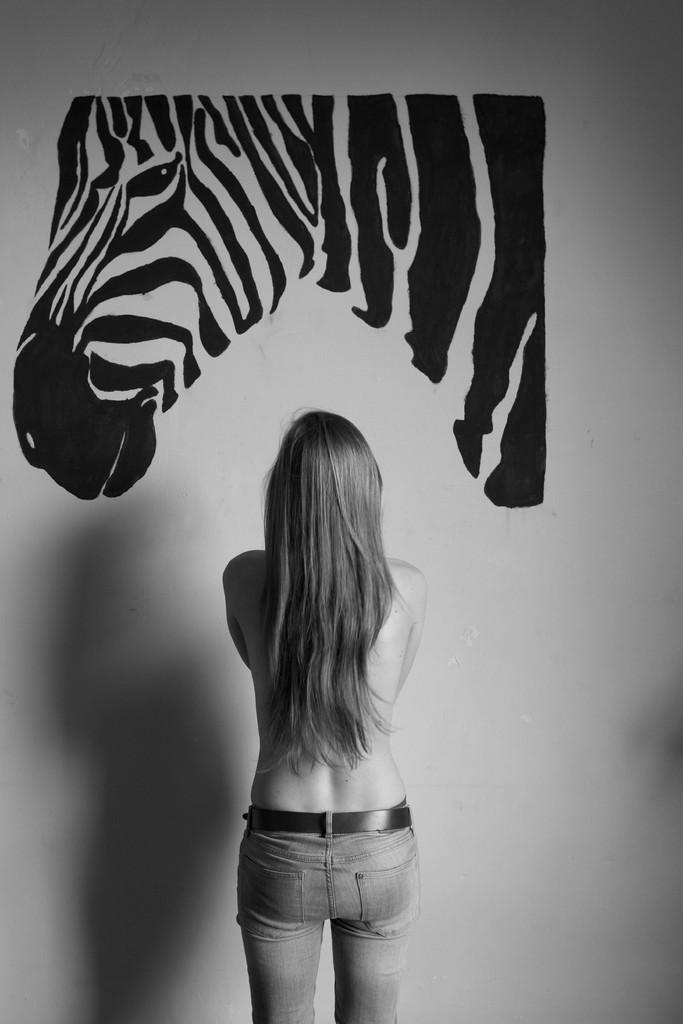What is the color scheme of the image? The image is black and white. Can you describe the woman's position in the image? There is a woman standing near a wall in the image. What is depicted on the wall in the image? There is a picture of a zebra on the wall. What degree does the woman have, as depicted in the image? There is no information about the woman's degree in the image. What disease is the zebra suffering from in the image? There is no indication of any disease in the image, and the zebra is a picture, not a living animal. 